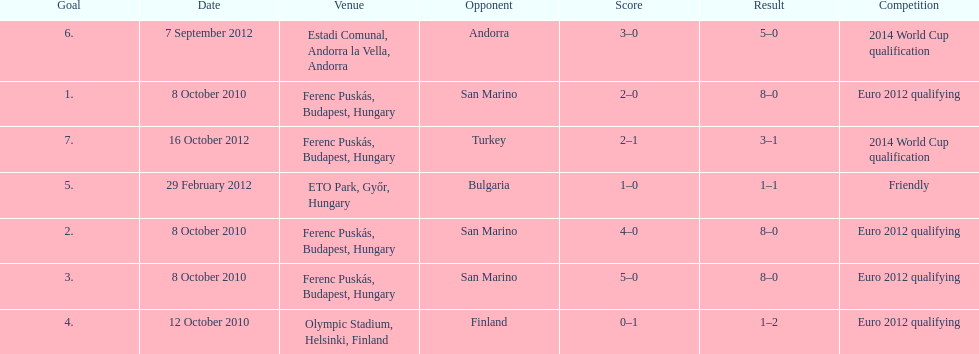When did ádám szalai make his first international goal? 8 October 2010. 